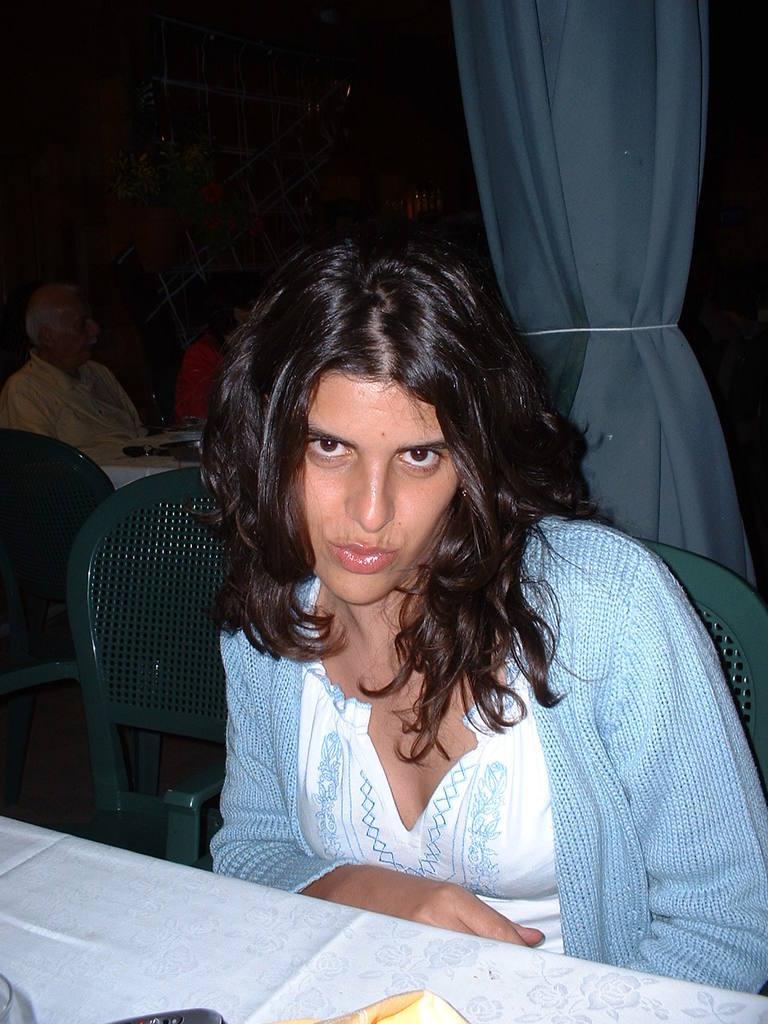How would you summarize this image in a sentence or two? This picture is mainly highlighted with a woman. She is wearing a blue sweater and she is sitting on a chair in front of a table. We can see a pot on her face. On the background of the picture we can see a white curtain and few persons sitting on a chair in front of a table. 